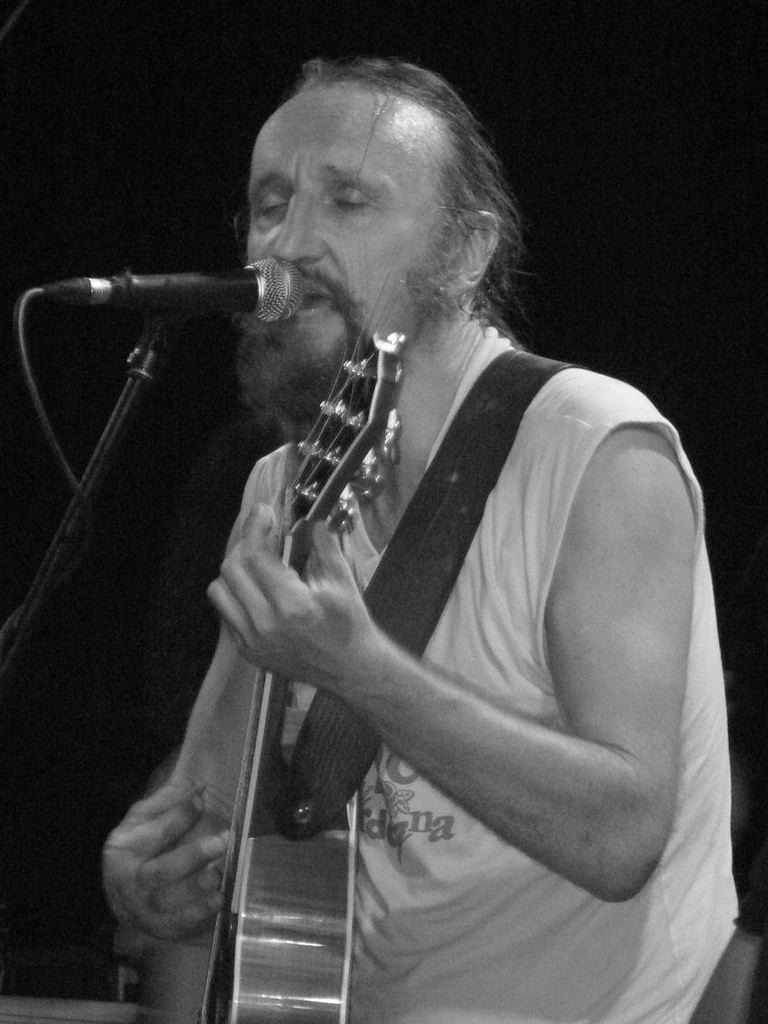Describe this image in one or two sentences. It is a black and white image. In this image person is singing a song by wearing a guitar. In front of the person there is a mike. 